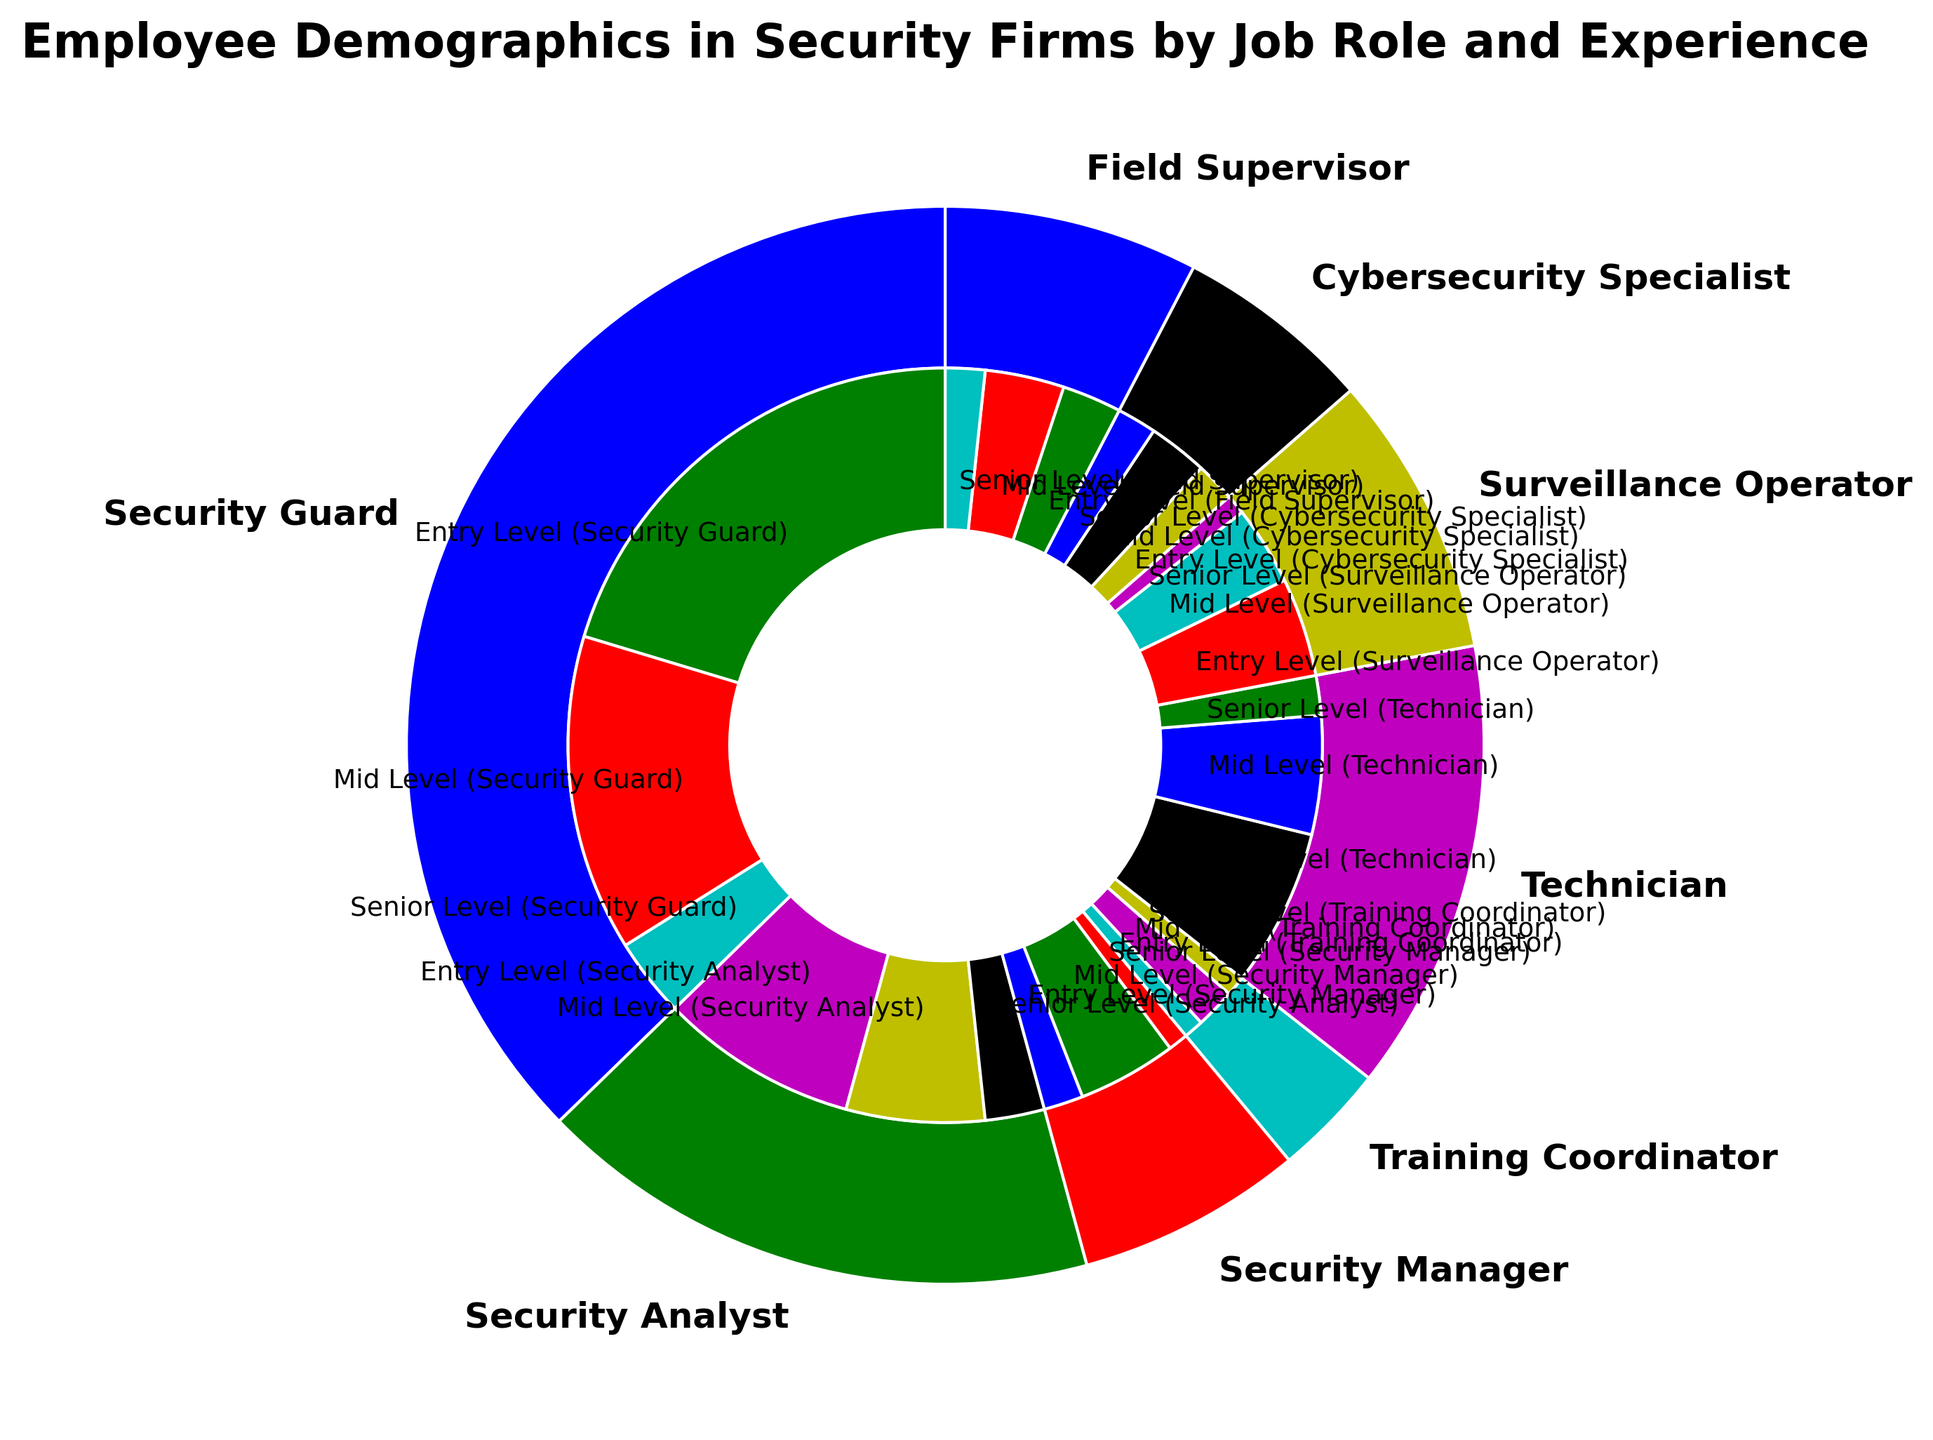What job role has the highest number of employees? Look at the outer pie chart and identify the slice with the largest area. "Security Guard" has the highest number of employees as its slice is the largest.
Answer: Security Guard What is the total number of Mid Level employees across all job roles? Identify the slices labeled as "Mid Level" in the inner pie chart, then sum their counts: Security Guard (80) + Security Analyst (35) + Security Manager (25) + Training Coordinator (10) + Technician (30) + Surveillance Operator (20) + Cybersecurity Specialist (15) + Field Supervisor (20) = 235.
Answer: 235 Which job role has more Senior Level employees, Security Analyst or Training Coordinator? Look at the inner pie chart slices labeled "Senior Level" for both job roles and compare the counts: Security Analyst (15) vs. Training Coordinator (5).
Answer: Security Analyst What is the proportion of Entry Level Security Guards among all Entry Level employees? Identify the count of Entry Level Security Guards (120) and the total count of all Entry Level employees: Security Guard (120) + Security Analyst (50) + Security Manager (10) + Training Coordinator (5) + Technician (40) + Surveillance Operator (25) + Cybersecurity Specialist (10) + Field Supervisor (15) = 275. Calculate the proportion: 120 / 275.
Answer: 43.6% How many more Entry Level employees are there compared to Senior Level employees in the Technician role? Identify the counts of Entry Level (40) and Senior Level (10) Technicians, then calculate the difference: 40 - 10 = 30.
Answer: 30 What job role has the smallest number of employees, and how many employees are there in this role? Identify the job role with the smallest slice in the outer pie chart. "Training Coordinator" has the smallest slice, and adding up its counts: Entry Level (5) + Mid Level (10) + Senior Level (5) = 20.
Answer: Training Coordinator, 20 Between Security Managers and Field Supervisors, who has more total employees, and by how much? Sum the counts for both roles: Security Manager (10 + 25 + 5 = 40) and Field Supervisor (15 + 20 + 10 = 45). Compare the totals: 45 - 40 = 5.
Answer: Field Supervisor, 5 Which experience level has the highest count in the Cybersecurity Specialist role? Look at the slices in the inner pie chart for Cybersecurity Specialist and identify the largest: Entry Level (10), Mid Level (15), Senior Level (10). Mid Level is the highest.
Answer: Mid Level What is the combined count of Senior Level employees across all job roles? Sum the counts of Senior Level employees: Security Guard (20) + Security Analyst (15) + Security Manager (5) + Training Coordinator (5) + Technician (10) + Surveillance Operator (5) + Cybersecurity Specialist (10) + Field Supervisor (10) = 80.
Answer: 80 